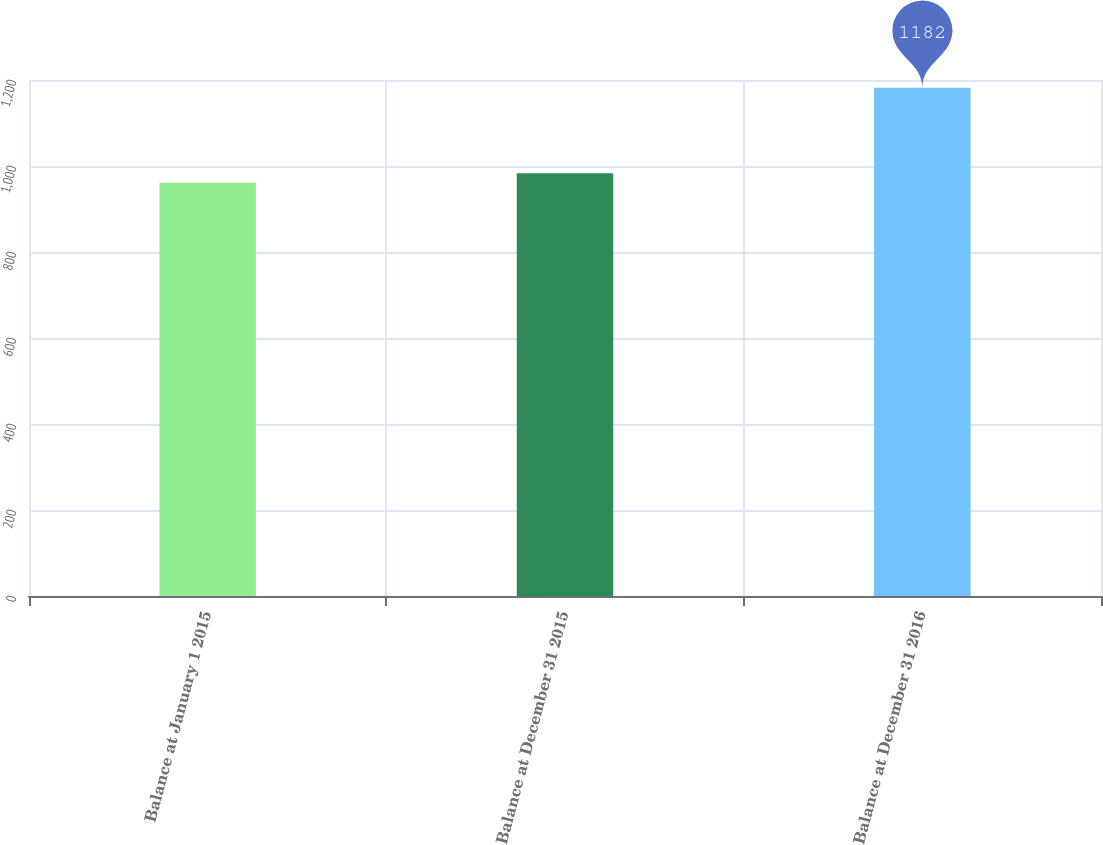Convert chart. <chart><loc_0><loc_0><loc_500><loc_500><bar_chart><fcel>Balance at January 1 2015<fcel>Balance at December 31 2015<fcel>Balance at December 31 2016<nl><fcel>961<fcel>983.1<fcel>1182<nl></chart> 